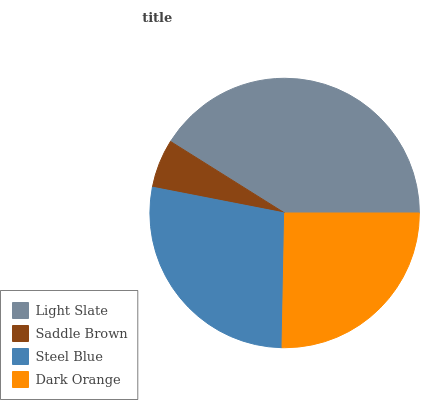Is Saddle Brown the minimum?
Answer yes or no. Yes. Is Light Slate the maximum?
Answer yes or no. Yes. Is Steel Blue the minimum?
Answer yes or no. No. Is Steel Blue the maximum?
Answer yes or no. No. Is Steel Blue greater than Saddle Brown?
Answer yes or no. Yes. Is Saddle Brown less than Steel Blue?
Answer yes or no. Yes. Is Saddle Brown greater than Steel Blue?
Answer yes or no. No. Is Steel Blue less than Saddle Brown?
Answer yes or no. No. Is Steel Blue the high median?
Answer yes or no. Yes. Is Dark Orange the low median?
Answer yes or no. Yes. Is Light Slate the high median?
Answer yes or no. No. Is Light Slate the low median?
Answer yes or no. No. 